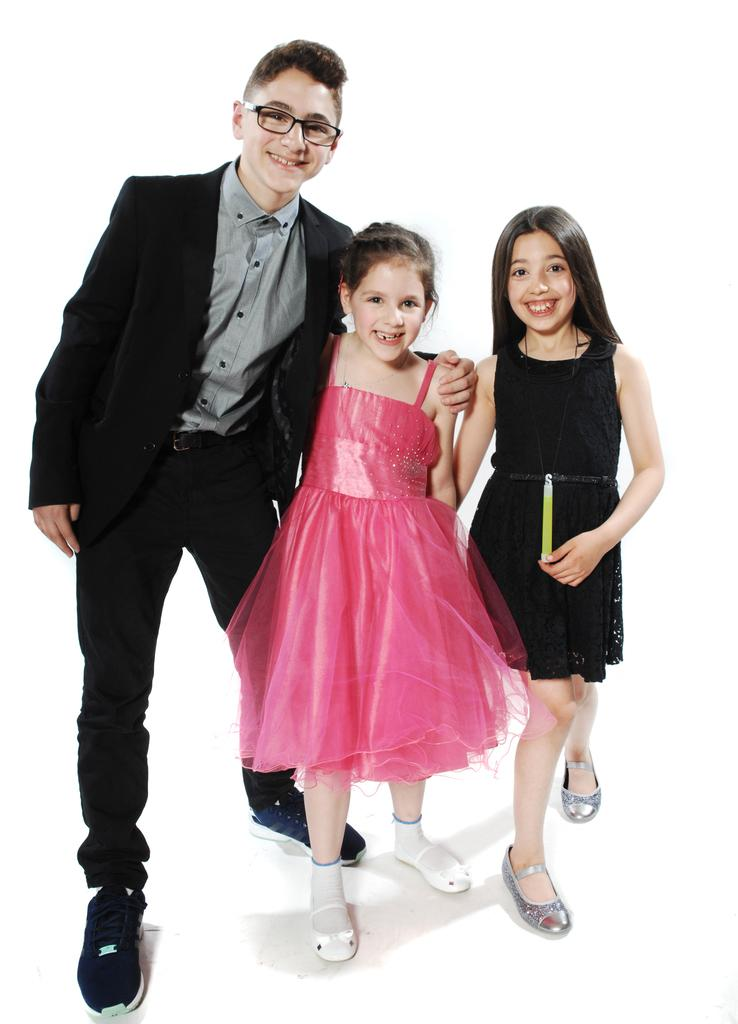How many children are present in the image? There are three children in the image. What are the children doing in the image? The children are standing on a surface. What type of horn can be seen on the rabbits in the image? There are no rabbits or horns present in the image; it features three children standing on a surface. 